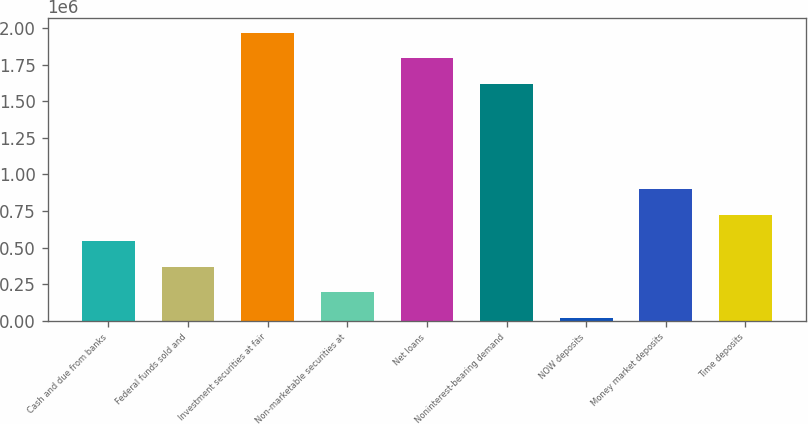Convert chart to OTSL. <chart><loc_0><loc_0><loc_500><loc_500><bar_chart><fcel>Cash and due from banks<fcel>Federal funds sold and<fcel>Investment securities at fair<fcel>Non-marketable securities at<fcel>Net loans<fcel>Noninterest-bearing demand<fcel>NOW deposits<fcel>Money market deposits<fcel>Time deposits<nl><fcel>542808<fcel>368788<fcel>1.96718e+06<fcel>194769<fcel>1.79316e+06<fcel>1.61914e+06<fcel>20750<fcel>896906<fcel>722887<nl></chart> 